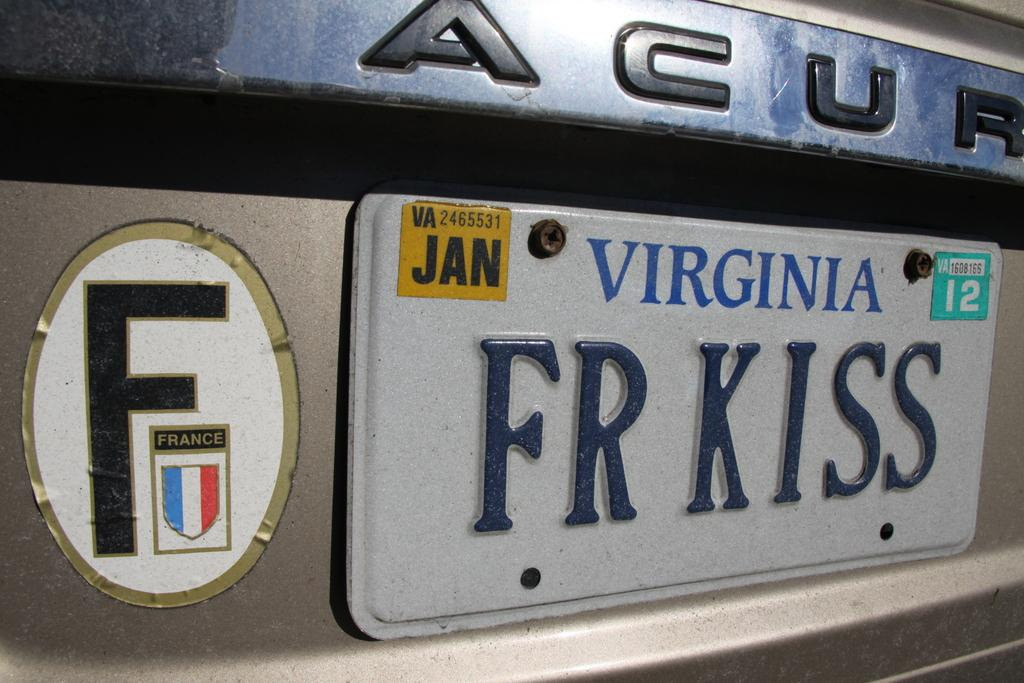<image>
Summarize the visual content of the image. A close up of an Acura with a Virginia license plate that says FR KISS 